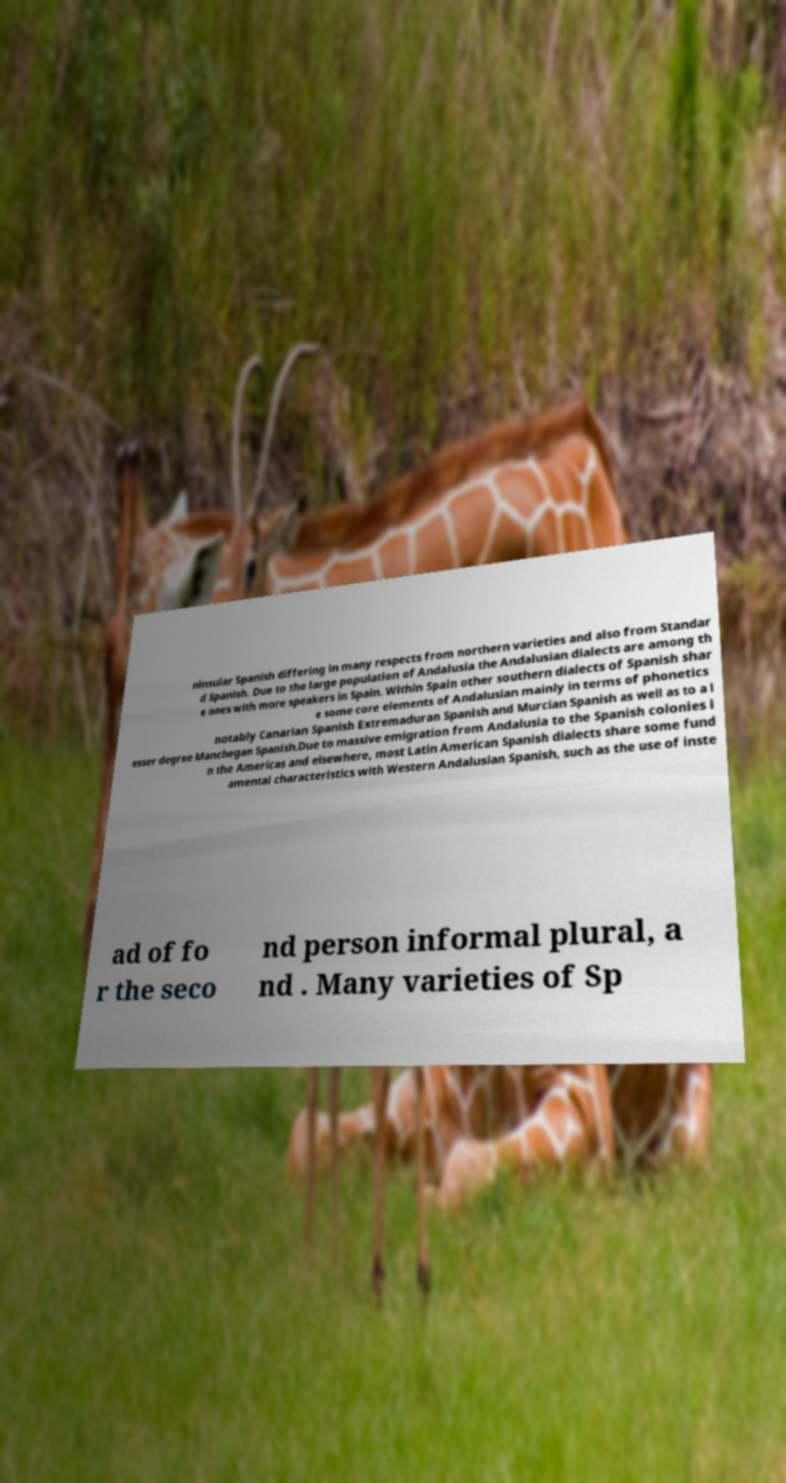Please identify and transcribe the text found in this image. ninsular Spanish differing in many respects from northern varieties and also from Standar d Spanish. Due to the large population of Andalusia the Andalusian dialects are among th e ones with more speakers in Spain. Within Spain other southern dialects of Spanish shar e some core elements of Andalusian mainly in terms of phonetics notably Canarian Spanish Extremaduran Spanish and Murcian Spanish as well as to a l esser degree Manchegan Spanish.Due to massive emigration from Andalusia to the Spanish colonies i n the Americas and elsewhere, most Latin American Spanish dialects share some fund amental characteristics with Western Andalusian Spanish, such as the use of inste ad of fo r the seco nd person informal plural, a nd . Many varieties of Sp 